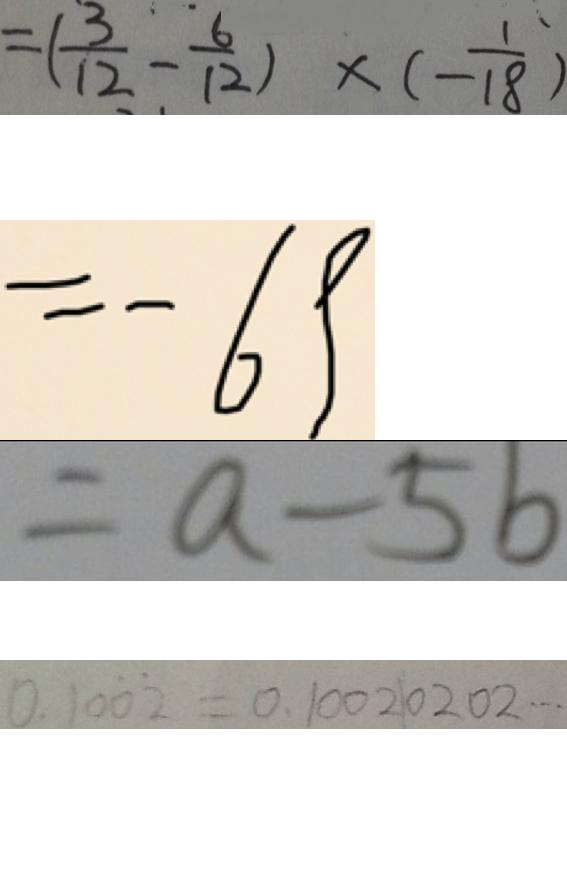<formula> <loc_0><loc_0><loc_500><loc_500>= ( \frac { 3 } { 1 2 } - \frac { 6 } { 1 2 } ) \times ( - \frac { 1 } { 1 8 } ) 
 = - 6 9 
 = a - 5 6 
 0 . 1 0 \dot { 0 } \dot { 2 } = 0 . 1 0 0 2 0 2 0 2 \cdots</formula> 